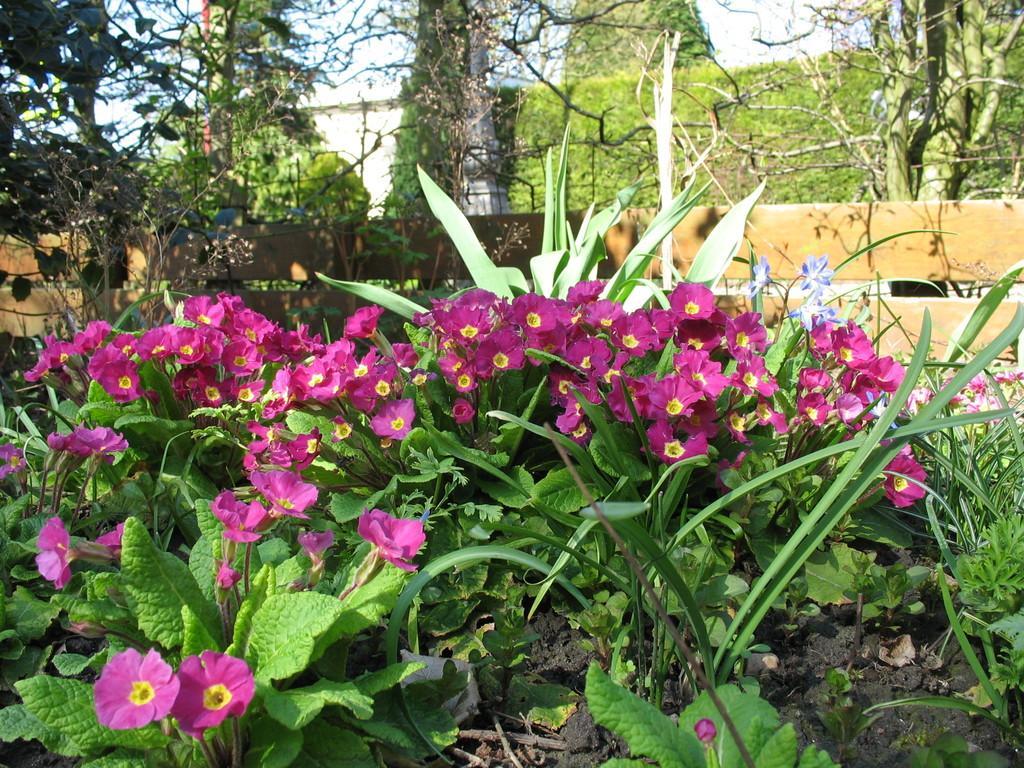Can you describe this image briefly? This picture is clicked outside. In the foreground we can see the pink color flowers, plants and in the center we can see the wooden fence, trees and some other objects. In the background we can see the sky and some other objects. 